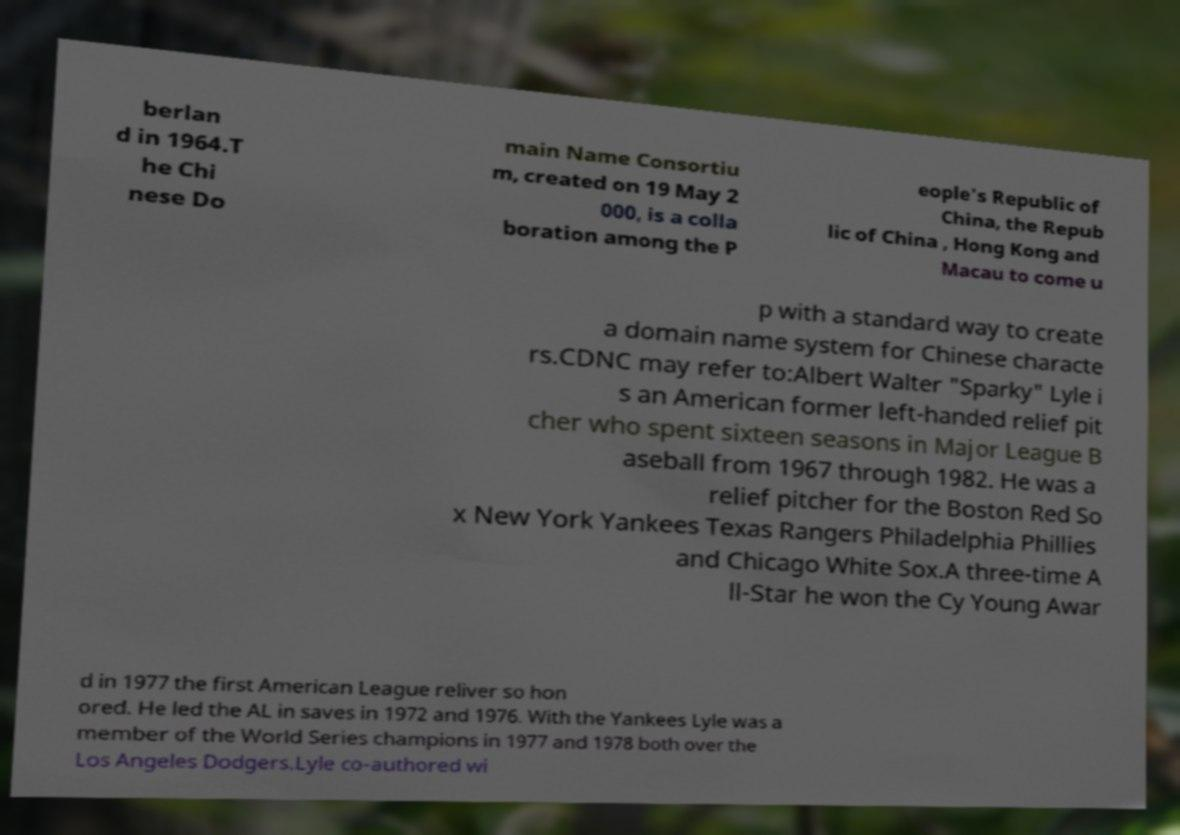Please identify and transcribe the text found in this image. berlan d in 1964.T he Chi nese Do main Name Consortiu m, created on 19 May 2 000, is a colla boration among the P eople's Republic of China, the Repub lic of China , Hong Kong and Macau to come u p with a standard way to create a domain name system for Chinese characte rs.CDNC may refer to:Albert Walter "Sparky" Lyle i s an American former left-handed relief pit cher who spent sixteen seasons in Major League B aseball from 1967 through 1982. He was a relief pitcher for the Boston Red So x New York Yankees Texas Rangers Philadelphia Phillies and Chicago White Sox.A three-time A ll-Star he won the Cy Young Awar d in 1977 the first American League reliver so hon ored. He led the AL in saves in 1972 and 1976. With the Yankees Lyle was a member of the World Series champions in 1977 and 1978 both over the Los Angeles Dodgers.Lyle co-authored wi 